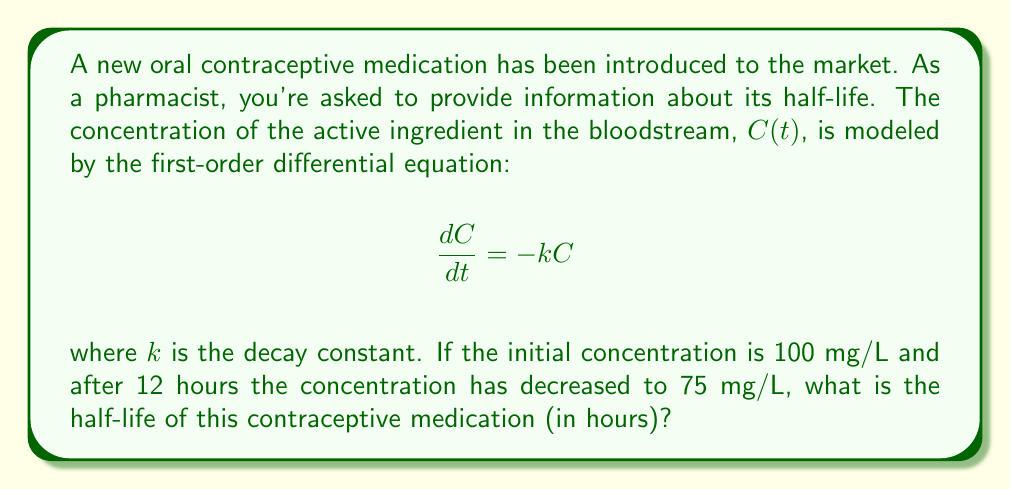What is the answer to this math problem? To solve this problem, we'll follow these steps:

1) First, we need to solve the differential equation. The general solution is:

   $$C(t) = C_0e^{-kt}$$

   where $C_0$ is the initial concentration.

2) We're given that $C_0 = 100$ mg/L and after 12 hours, $C(12) = 75$ mg/L. Let's substitute these into our equation:

   $$75 = 100e^{-12k}$$

3) Divide both sides by 100:

   $$0.75 = e^{-12k}$$

4) Take the natural log of both sides:

   $$\ln(0.75) = -12k$$

5) Solve for $k$:

   $$k = -\frac{\ln(0.75)}{12} \approx 0.0239$$

6) Now that we have $k$, we can calculate the half-life. The half-life $t_{1/2}$ is the time it takes for the concentration to decrease to half its initial value. It's given by:

   $$t_{1/2} = \frac{\ln(2)}{k}$$

7) Substitute our value of $k$:

   $$t_{1/2} = \frac{\ln(2)}{0.0239} \approx 29.0$$

Therefore, the half-life of the contraceptive medication is approximately 29.0 hours.
Answer: The half-life of the contraceptive medication is approximately 29.0 hours. 